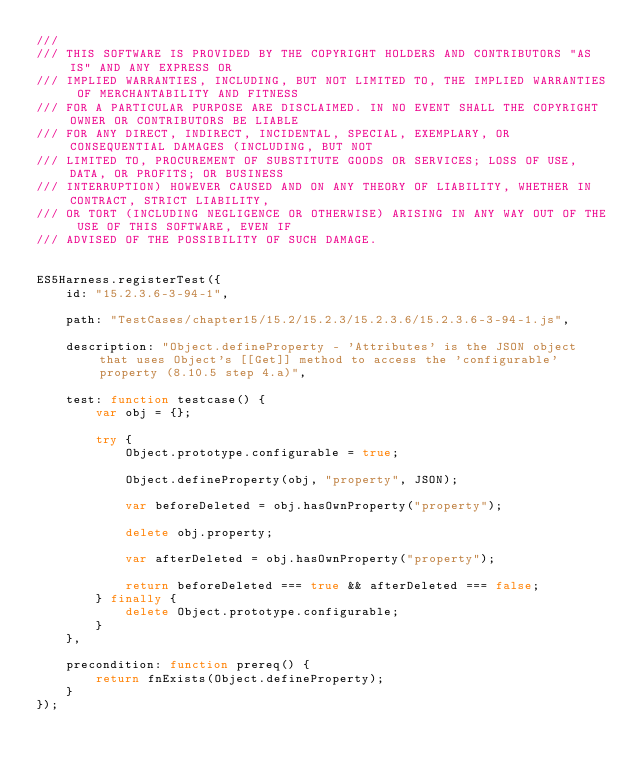<code> <loc_0><loc_0><loc_500><loc_500><_JavaScript_>/// 
/// THIS SOFTWARE IS PROVIDED BY THE COPYRIGHT HOLDERS AND CONTRIBUTORS "AS IS" AND ANY EXPRESS OR
/// IMPLIED WARRANTIES, INCLUDING, BUT NOT LIMITED TO, THE IMPLIED WARRANTIES OF MERCHANTABILITY AND FITNESS
/// FOR A PARTICULAR PURPOSE ARE DISCLAIMED. IN NO EVENT SHALL THE COPYRIGHT OWNER OR CONTRIBUTORS BE LIABLE
/// FOR ANY DIRECT, INDIRECT, INCIDENTAL, SPECIAL, EXEMPLARY, OR CONSEQUENTIAL DAMAGES (INCLUDING, BUT NOT
/// LIMITED TO, PROCUREMENT OF SUBSTITUTE GOODS OR SERVICES; LOSS OF USE, DATA, OR PROFITS; OR BUSINESS
/// INTERRUPTION) HOWEVER CAUSED AND ON ANY THEORY OF LIABILITY, WHETHER IN CONTRACT, STRICT LIABILITY,
/// OR TORT (INCLUDING NEGLIGENCE OR OTHERWISE) ARISING IN ANY WAY OUT OF THE USE OF THIS SOFTWARE, EVEN IF
/// ADVISED OF THE POSSIBILITY OF SUCH DAMAGE.


ES5Harness.registerTest({
    id: "15.2.3.6-3-94-1",

    path: "TestCases/chapter15/15.2/15.2.3/15.2.3.6/15.2.3.6-3-94-1.js",

    description: "Object.defineProperty - 'Attributes' is the JSON object that uses Object's [[Get]] method to access the 'configurable' property (8.10.5 step 4.a)",

    test: function testcase() {
        var obj = {};

        try {
            Object.prototype.configurable = true;

            Object.defineProperty(obj, "property", JSON);

            var beforeDeleted = obj.hasOwnProperty("property");

            delete obj.property;

            var afterDeleted = obj.hasOwnProperty("property");

            return beforeDeleted === true && afterDeleted === false;
        } finally {
            delete Object.prototype.configurable;
        }
    },

    precondition: function prereq() {
        return fnExists(Object.defineProperty);
    }
});
</code> 